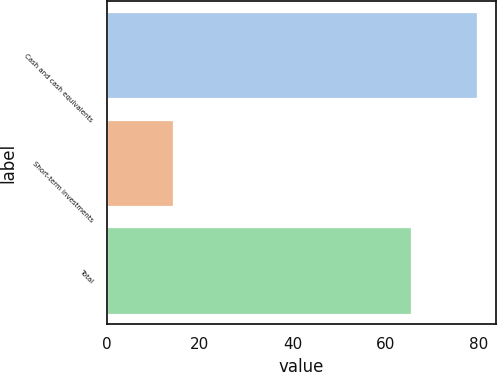Convert chart to OTSL. <chart><loc_0><loc_0><loc_500><loc_500><bar_chart><fcel>Cash and cash equivalents<fcel>Short-term investments<fcel>Total<nl><fcel>79.7<fcel>14.2<fcel>65.5<nl></chart> 